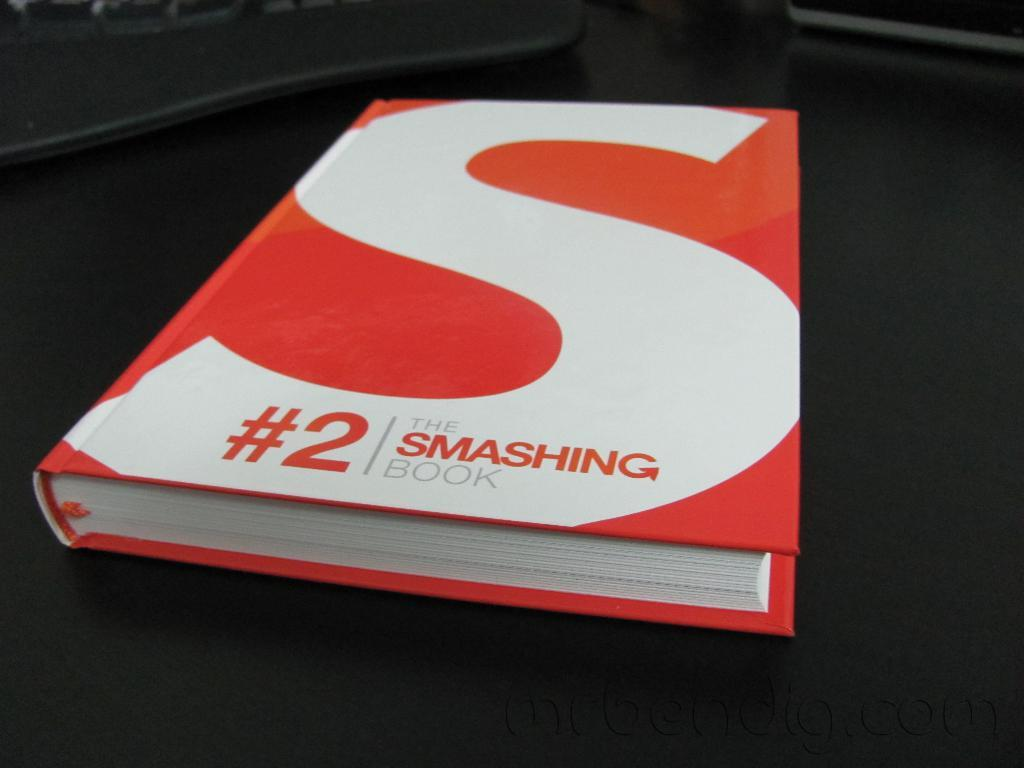What object can be seen in the picture? There is a book in the picture. What is the book placed on? The book is on a black surface. What colors are present on the book's cover? The book has a white and red cover. How many birds are in the flock that is sitting on the book's cover? There is no flock of birds present on the book's cover; it has a white and red design. 